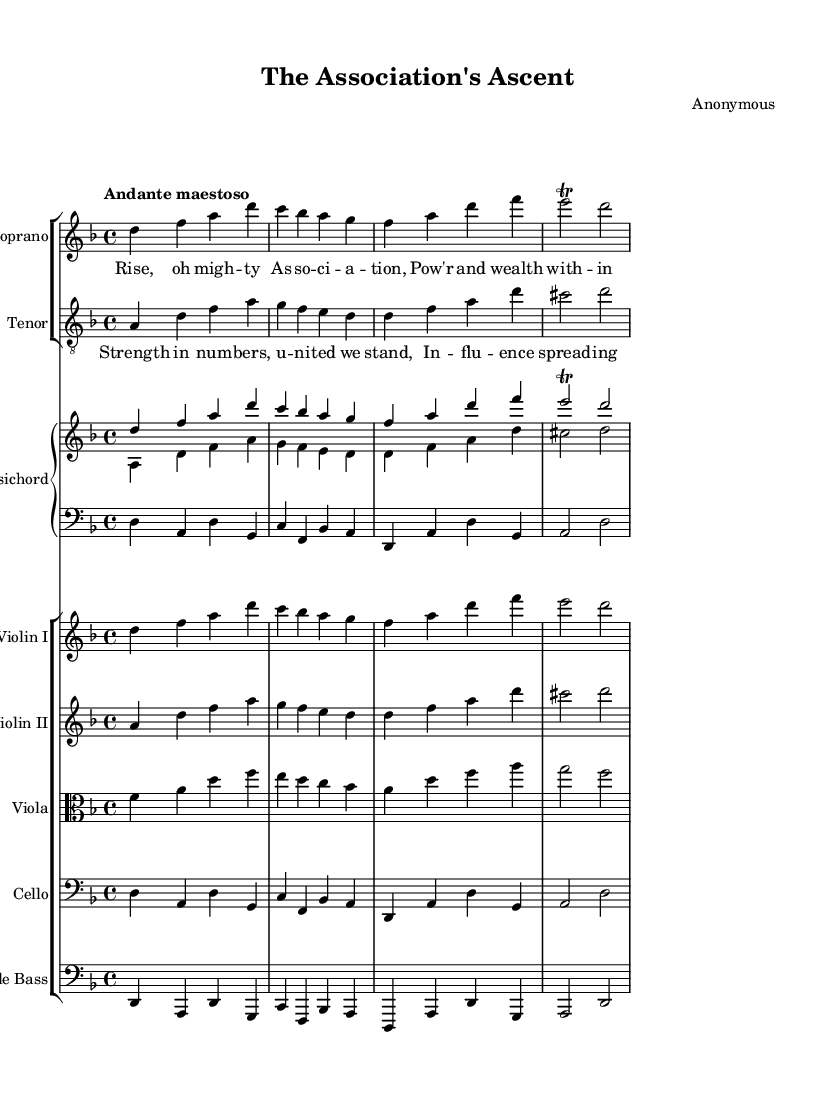What is the key signature of this music? The key signature is identified by the sharp or flat symbols at the beginning of the staff. In this case, there are no sharps or flats indicated, which indicates that the piece is in D minor.
Answer: D minor What is the time signature of this piece? The time signature is shown as a fraction at the beginning of the staff, indicating how the beats are organized. Here, it is 4/4, which means there are four beats in each measure.
Answer: 4/4 What is the tempo marking for this piece? The tempo marking appears above the staff and indicates the speed at which the piece should be played. It reads "Andante maestoso," which describes a moderately slow tempo with a dignified manner.
Answer: Andante maestoso How many staves are used for the vocal parts? The vocal parts consist of two distinct staves: one for the soprano and one for the tenor, as indicated by the labels.
Answer: Two Which instruments accompany the vocal parts? The accompanying instruments are typically shown on separate staves. In this piece, the instrumentation includes a harpsichord and a string ensemble with violin I, violin II, viola, cello, and double bass.
Answer: Harpsichord and strings What is the thematic focus of the lyrics in the soprano part? The lyrics for the soprano part emphasize themes of strength and power related to the trade association. The phrase "Rise, oh mighty Association" indicates the aspiration for growth and influence.
Answer: Power and wealth What structural form is commonly found in operatic pieces similar to this one? Operatic compositions often utilize structured forms such as arias, duets, and choruses. In this music, the combination of vocal lines and instrumental accompaniment suggests a choral form, typical in opera.
Answer: Choral form 